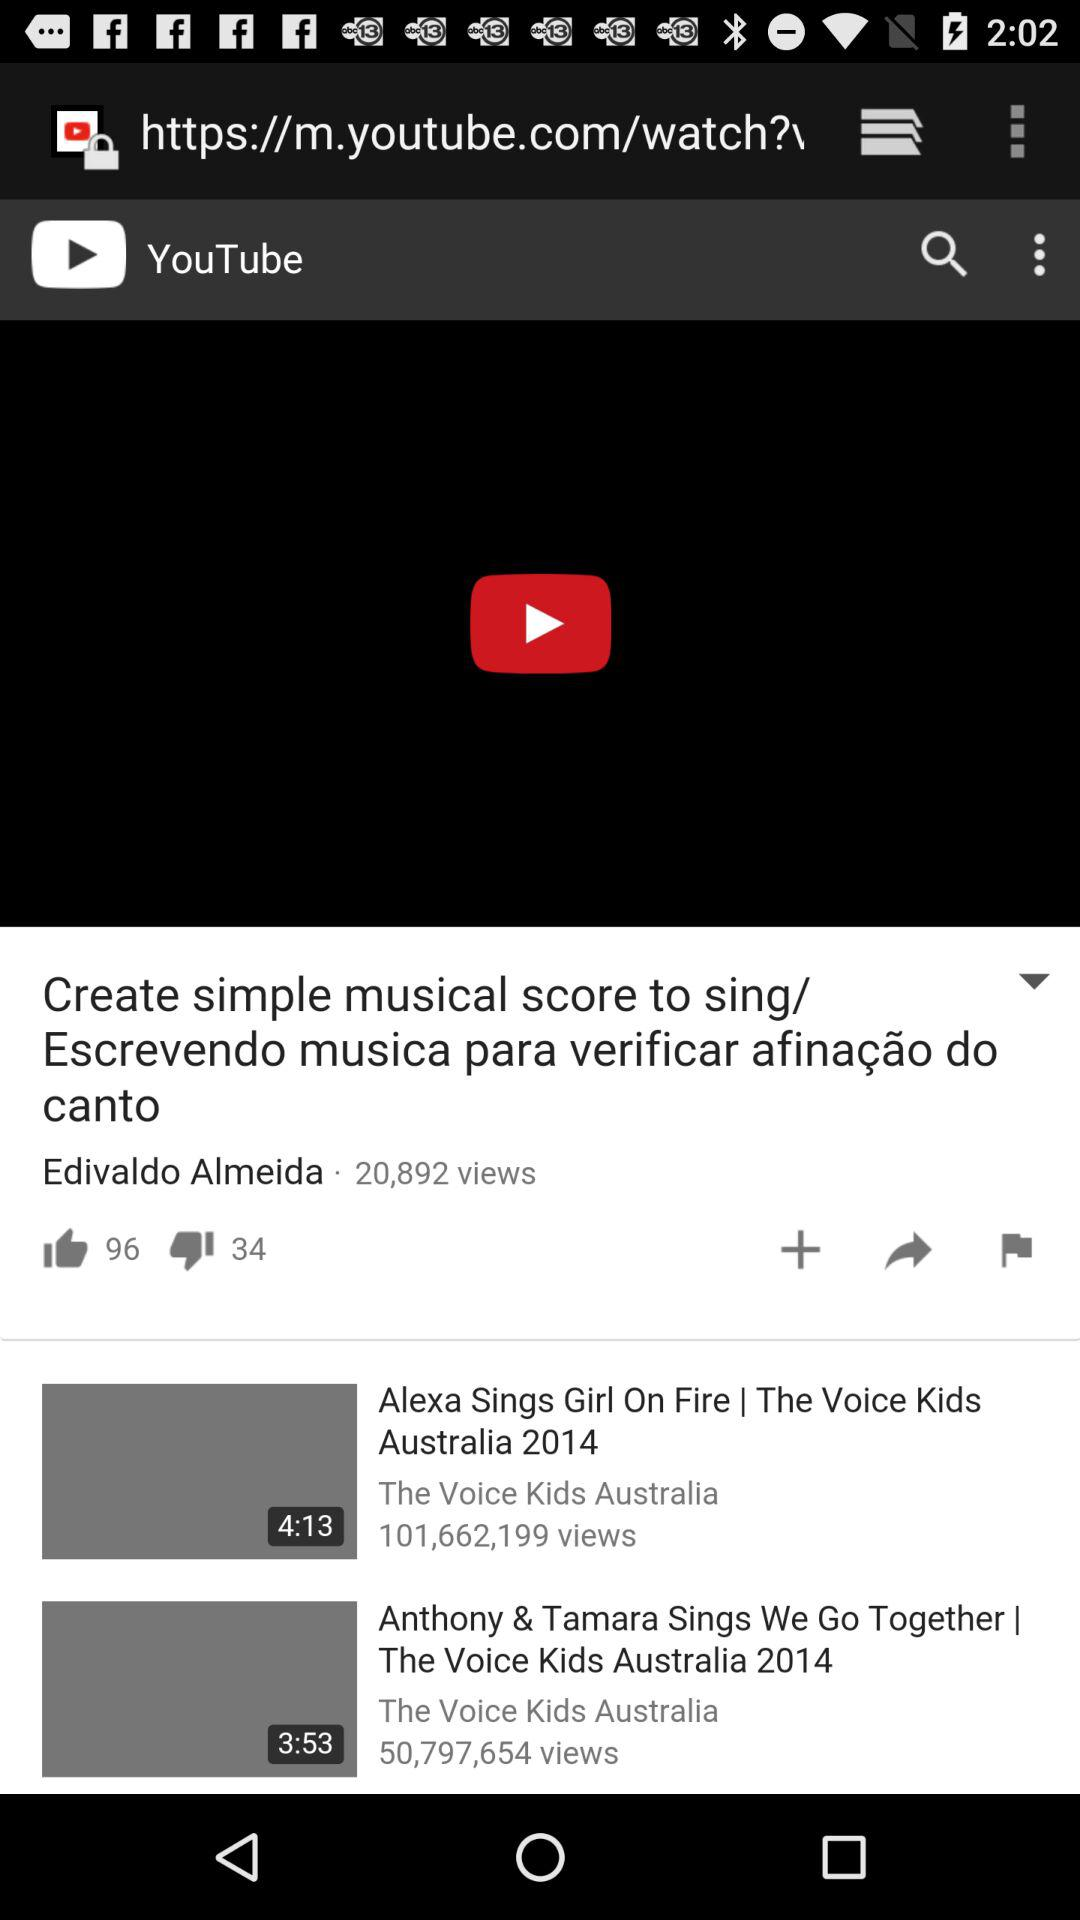How many views are there of the "Create simple musical score to sing/ Escrevendo musica para verificar afinação do canto" video? There are 20,892 views in the video. 